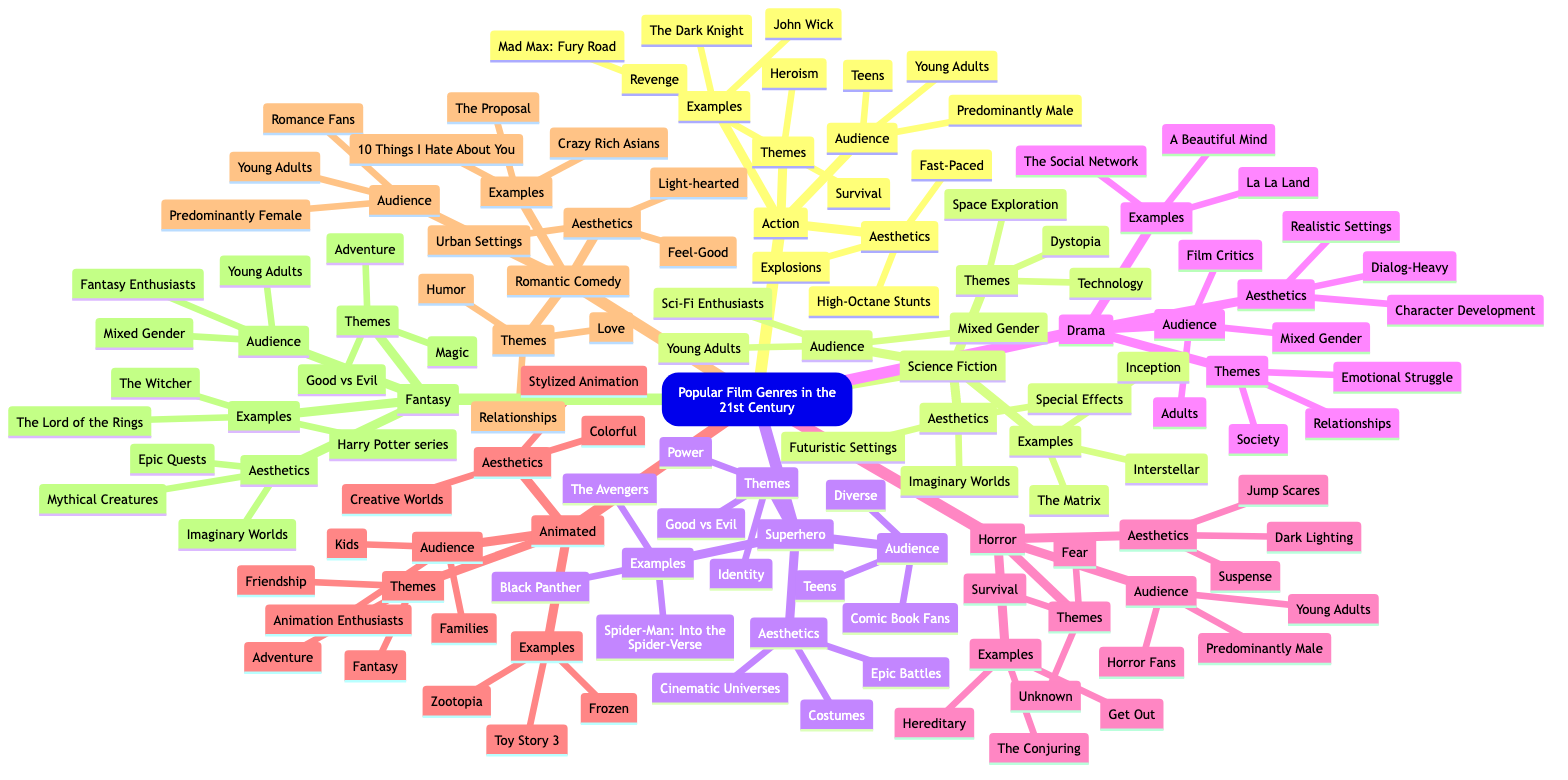What are the main themes of the Action genre? The diagram lists three main themes under the Action genre: Heroism, Revenge, and Survival. I identify these by locating the Action branch and noting the associated themes.
Answer: Heroism, Revenge, Survival How many examples are given for the Horror genre? The Horror genre branch contains three specific examples listed: Get Out, The Conjuring, and Hereditary. I count them to arrive at the answer.
Answer: 3 Which audience demographic is associated predominantly with the Romantic Comedy genre? The diagram indicates that the Romantic Comedy genre has "Predominantly Female" within its audience demographics. I locate the Romantic Comedy audience section to find this information.
Answer: Predominantly Female What aesthetic elements are common in Science Fiction films? Under the Science Fiction genre, the aesthetic elements listed are Futuristic Settings, Special Effects, and Imaginary Worlds. By looking at the Aesthetics section of the Science Fiction branch, I find these elements.
Answer: Futuristic Settings, Special Effects, Imaginary Worlds Which genre includes themes of Magic and Adventure? The Fantasy genre is identified as including the themes of Magic and Adventure. I reference the themes listed under the Fantasy branch to arrive at the answer.
Answer: Fantasy What is the common audience demographic for both Action and Horror genres? Both the Action and Horror genres feature Young Adults as part of their audience demographics. I compare the audience sections of both genres to identify this commonality.
Answer: Young Adults Which genre features Epic Battles as part of its aesthetics? The Superhero genre lists Epic Battles among its aesthetic elements. I refer to the aesthetics of the Superhero section in the diagram to find this information.
Answer: Superhero What themes are shared between the Horror and Action genres? The themes of Fear and Survival are both found in the Horror genre, while Survival is also a theme in Action. I investigate the themes of both genres to identify these common themes.
Answer: Survival How many different film genres are listed in the diagram? The diagram contains eight distinct film genres: Action, Science Fiction, Superhero, Drama, Horror, Animated, Romantic Comedy, and Fantasy. I count the number of main genre branches to determine the total.
Answer: 8 